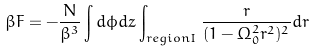<formula> <loc_0><loc_0><loc_500><loc_500>\beta F = - \frac { N } { \beta ^ { 3 } } \int d \phi d z \int _ { r e g i o n I } \frac { r } { ( 1 - \Omega _ { 0 } ^ { 2 } r ^ { 2 } ) ^ { 2 } } d r</formula> 